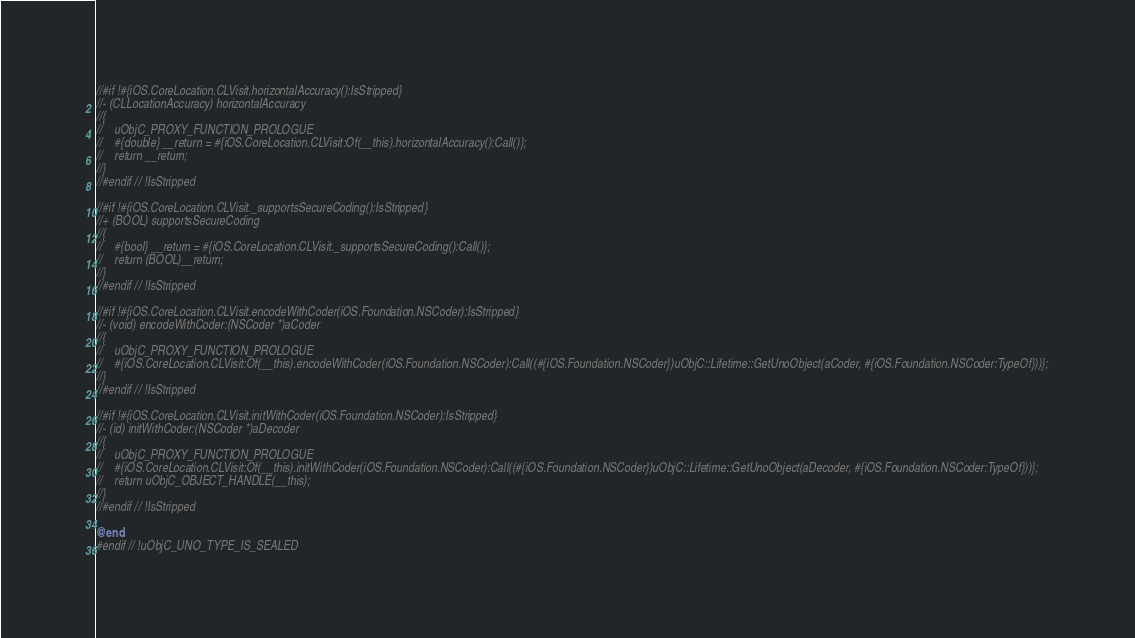<code> <loc_0><loc_0><loc_500><loc_500><_ObjectiveC_>//#if !#{iOS.CoreLocation.CLVisit.horizontalAccuracy():IsStripped}
//- (CLLocationAccuracy) horizontalAccuracy
//{
//    uObjC_PROXY_FUNCTION_PROLOGUE
//    #{double} __return = #{iOS.CoreLocation.CLVisit:Of(__this).horizontalAccuracy():Call()};
//    return __return;
//}
//#endif // !IsStripped

//#if !#{iOS.CoreLocation.CLVisit._supportsSecureCoding():IsStripped}
//+ (BOOL) supportsSecureCoding
//{
//    #{bool} __return = #{iOS.CoreLocation.CLVisit._supportsSecureCoding():Call()};
//    return (BOOL)__return;
//}
//#endif // !IsStripped

//#if !#{iOS.CoreLocation.CLVisit.encodeWithCoder(iOS.Foundation.NSCoder):IsStripped}
//- (void) encodeWithCoder:(NSCoder *)aCoder
//{
//    uObjC_PROXY_FUNCTION_PROLOGUE
//    #{iOS.CoreLocation.CLVisit:Of(__this).encodeWithCoder(iOS.Foundation.NSCoder):Call((#{iOS.Foundation.NSCoder})uObjC::Lifetime::GetUnoObject(aCoder, #{iOS.Foundation.NSCoder:TypeOf}))};
//}
//#endif // !IsStripped

//#if !#{iOS.CoreLocation.CLVisit.initWithCoder(iOS.Foundation.NSCoder):IsStripped}
//- (id) initWithCoder:(NSCoder *)aDecoder
//{
//    uObjC_PROXY_FUNCTION_PROLOGUE
//    #{iOS.CoreLocation.CLVisit:Of(__this).initWithCoder(iOS.Foundation.NSCoder):Call((#{iOS.Foundation.NSCoder})uObjC::Lifetime::GetUnoObject(aDecoder, #{iOS.Foundation.NSCoder:TypeOf}))};
//    return uObjC_OBJECT_HANDLE(__this);
//}
//#endif // !IsStripped

@end
#endif // !uObjC_UNO_TYPE_IS_SEALED
</code> 